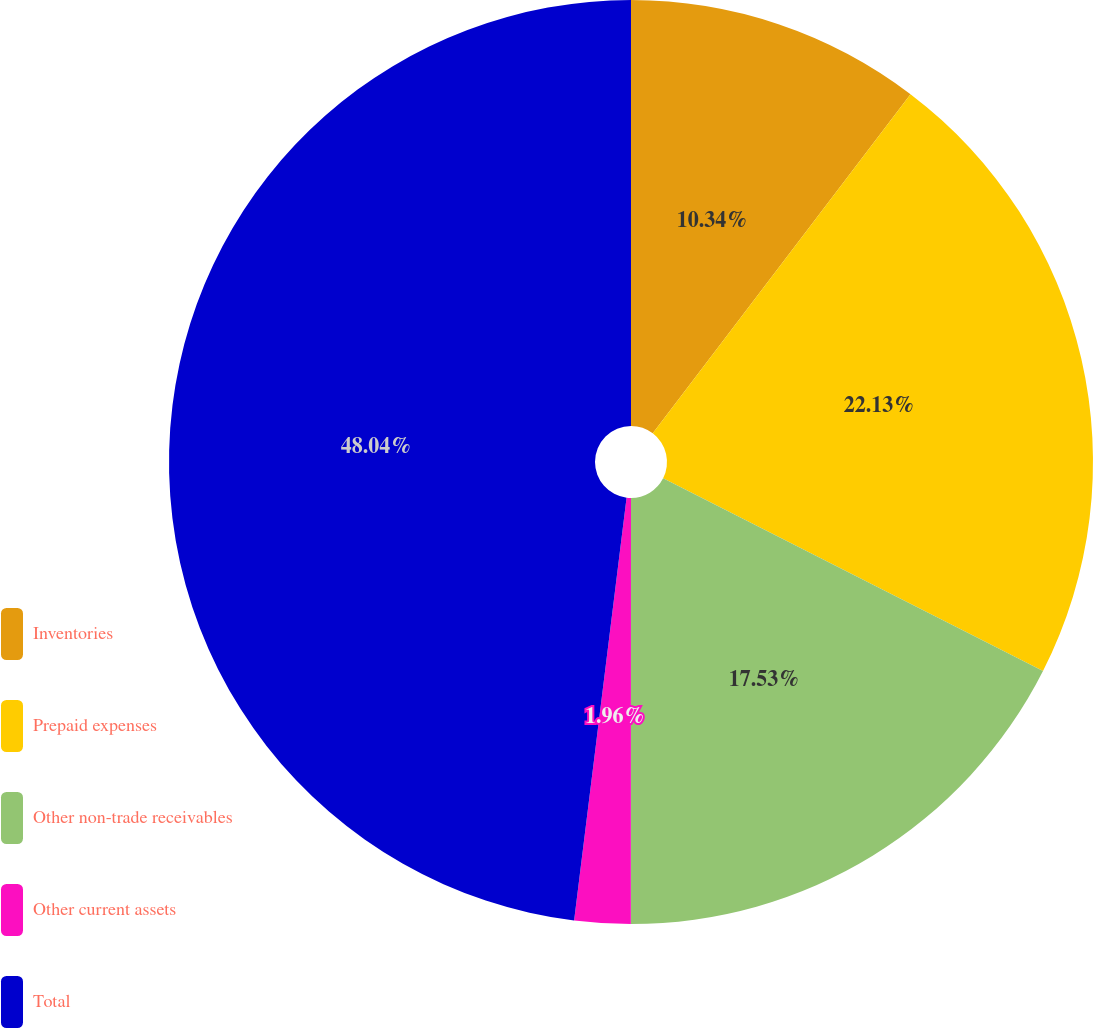Convert chart to OTSL. <chart><loc_0><loc_0><loc_500><loc_500><pie_chart><fcel>Inventories<fcel>Prepaid expenses<fcel>Other non-trade receivables<fcel>Other current assets<fcel>Total<nl><fcel>10.34%<fcel>22.13%<fcel>17.53%<fcel>1.96%<fcel>48.03%<nl></chart> 